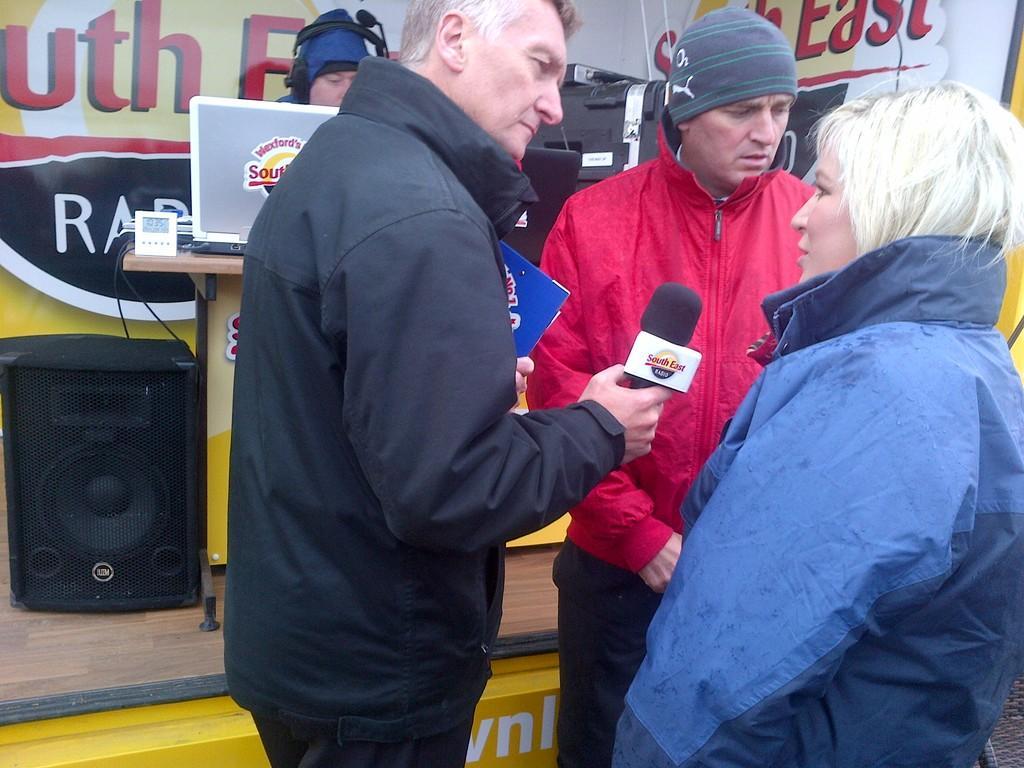In one or two sentences, can you explain what this image depicts? This image is taken outdoors. In the background there is a dais and there is a poster with a text on it. A man is sitting on the chair and there is a table with a few things on it and there is a speaker box on the dais. In the middle of the image a man is standing and he is holding a mic in his hand. On the right side of the image a man and a woman are standing. 